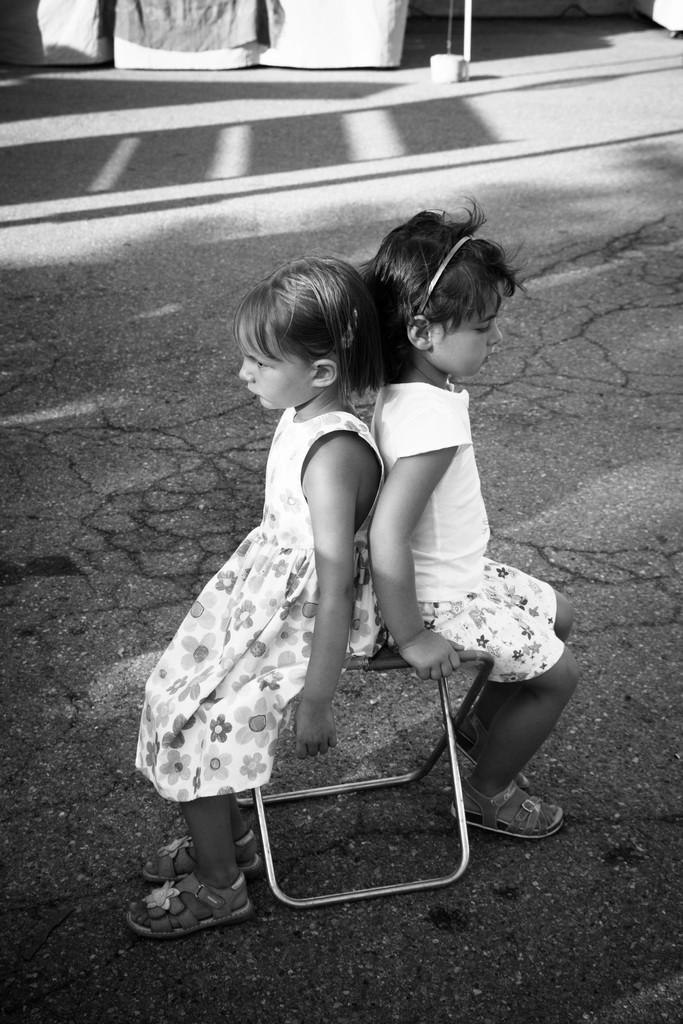Who is present in the image? There are kids in the image. What are the kids doing in the image? The kids are sitting on chairs. Can you describe the object at the top of the image? Unfortunately, the provided facts do not give any information about the object at the top of the image. What type of snow can be seen falling in the image? There is no snow present in the image. Can you describe the tub that the kids are using in the image? There is no tub present in the image; the kids are sitting on chairs. 